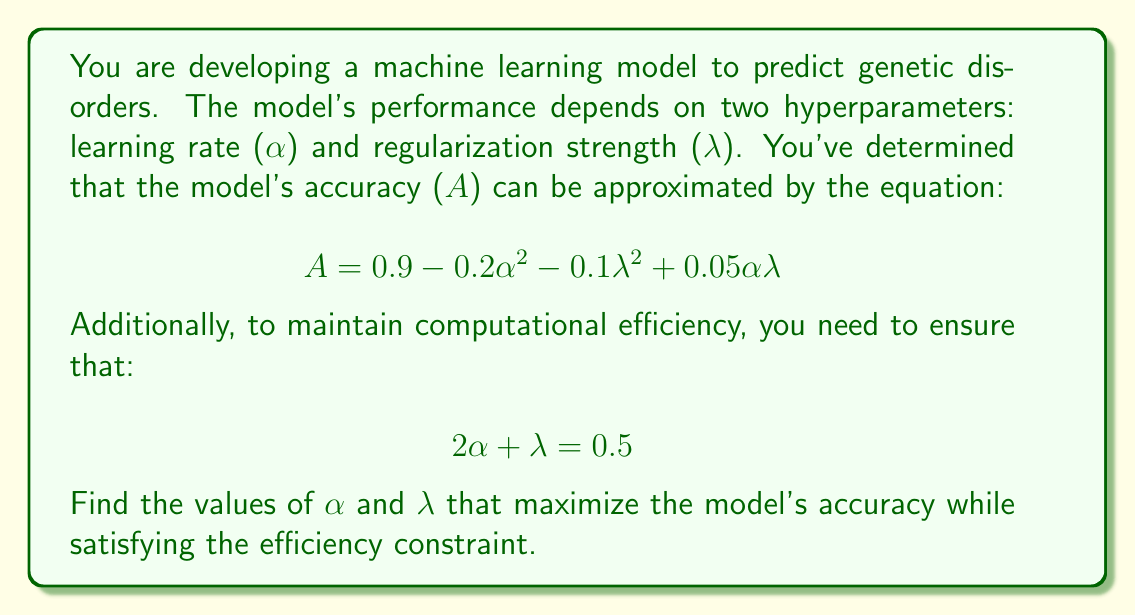Could you help me with this problem? To solve this optimization problem, we'll use the method of substitution and differentiation:

1) From the efficiency constraint, we can express $\lambda$ in terms of $\alpha$:
   $$\lambda = 0.5 - 2\alpha$$

2) Substitute this into the accuracy equation:
   $$A = 0.9 - 0.2\alpha^2 - 0.1(0.5 - 2\alpha)^2 + 0.05\alpha(0.5 - 2\alpha)$$

3) Expand the equation:
   $$A = 0.9 - 0.2\alpha^2 - 0.1(0.25 - 2\alpha + 4\alpha^2) + 0.025\alpha - 0.1\alpha^2$$
   $$A = 0.9 - 0.2\alpha^2 - 0.025 + 0.2\alpha - 0.4\alpha^2 + 0.025\alpha - 0.1\alpha^2$$
   $$A = 0.875 + 0.225\alpha - 0.7\alpha^2$$

4) To find the maximum, differentiate $A$ with respect to $\alpha$ and set it to zero:
   $$\frac{dA}{d\alpha} = 0.225 - 1.4\alpha = 0$$

5) Solve for $\alpha$:
   $$1.4\alpha = 0.225$$
   $$\alpha = \frac{0.225}{1.4} = 0.16071428...$$

6) Calculate $\lambda$ using the constraint equation:
   $$\lambda = 0.5 - 2(0.16071428...) = 0.17857142...$$

7) Verify that this is indeed a maximum by checking the second derivative:
   $$\frac{d^2A}{d\alpha^2} = -1.4 < 0$$
   Since the second derivative is negative, this critical point is a maximum.
Answer: The optimal hyperparameters are:
$\alpha \approx 0.1607$ (learning rate)
$\lambda \approx 0.1786$ (regularization strength)
These values maximize the model's accuracy while satisfying the efficiency constraint. 